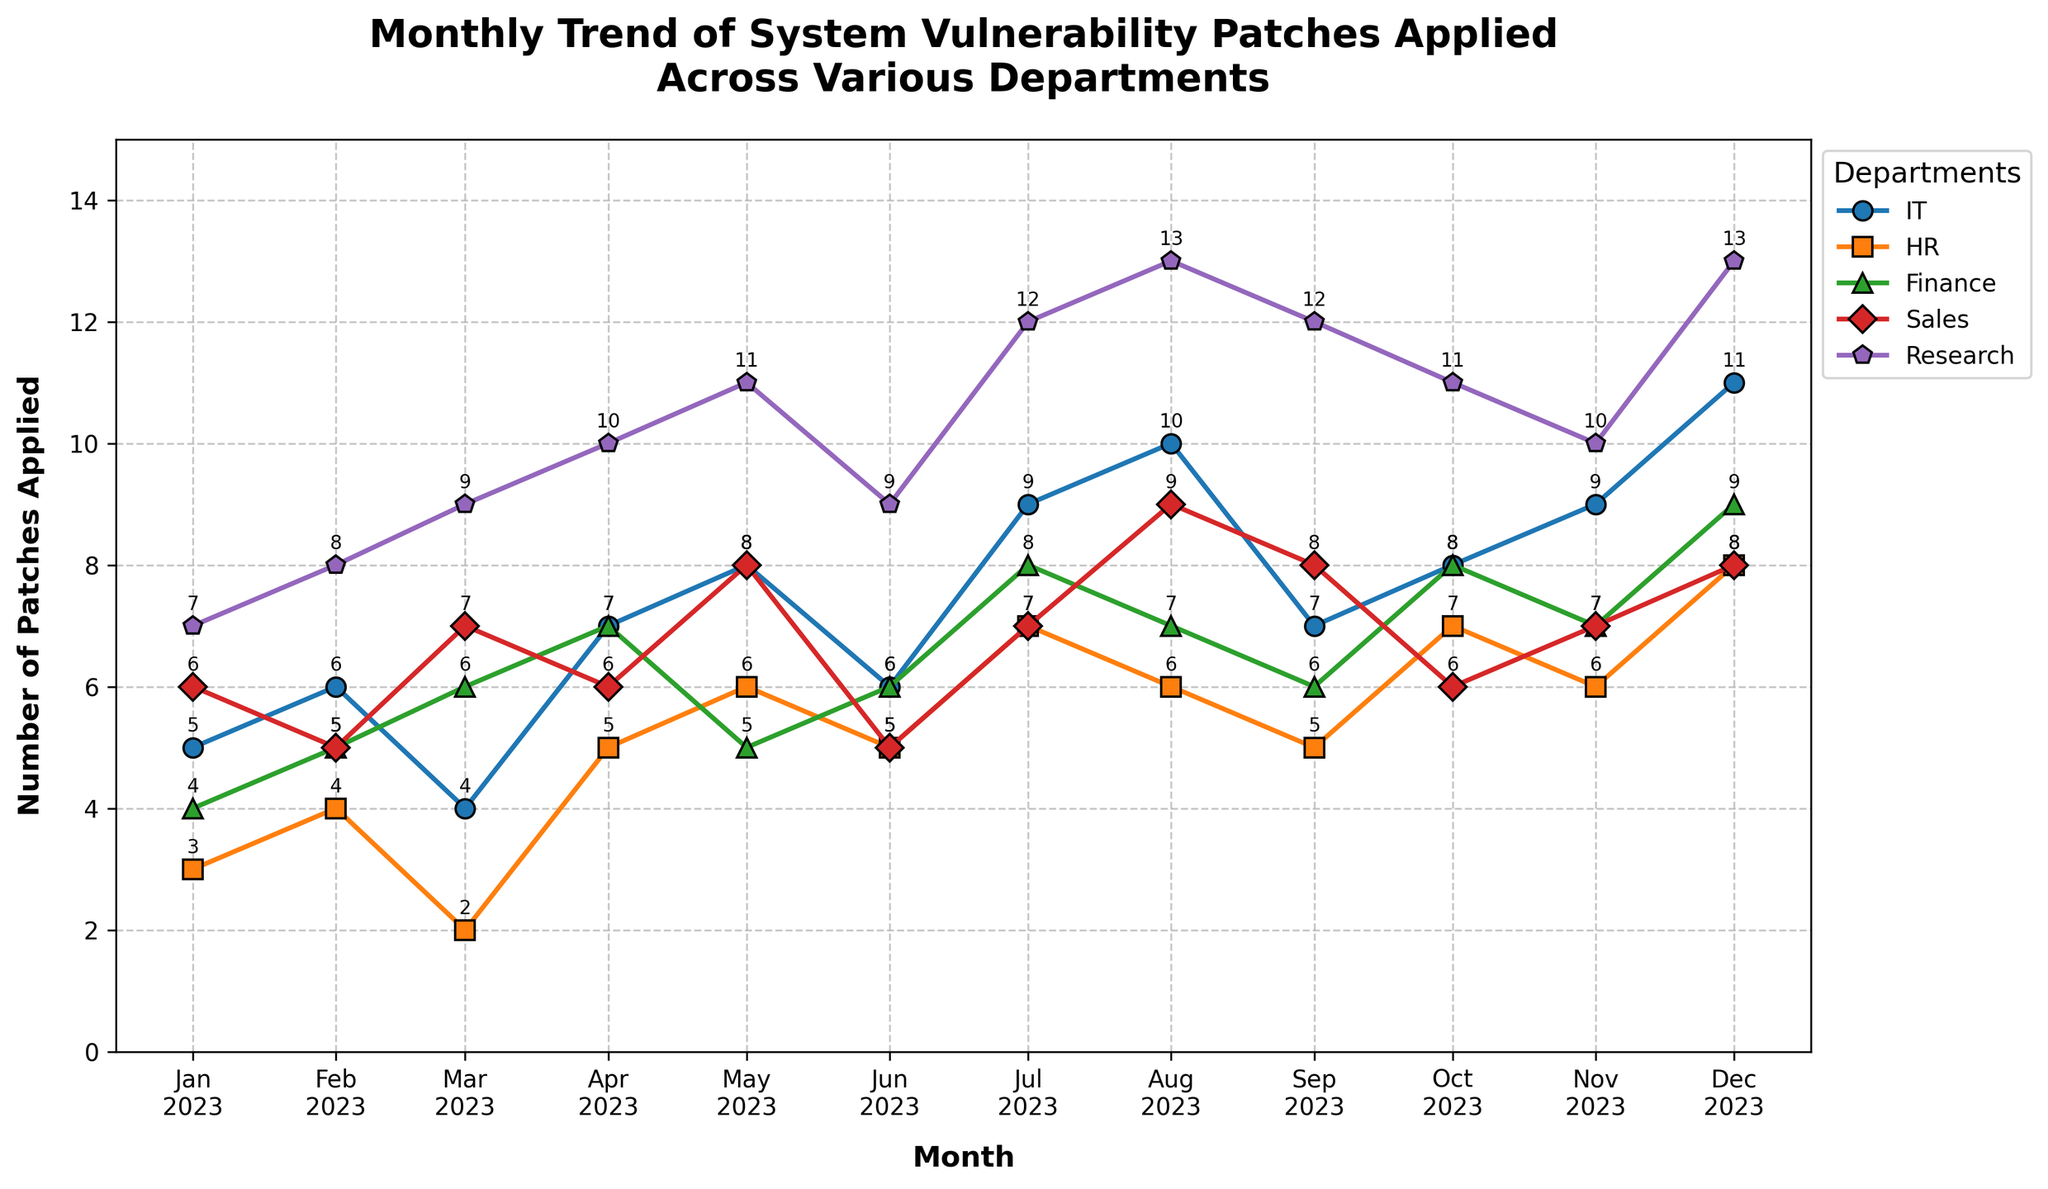What is the highest number of patches applied by the Research department in 2023? Observe the vertical axis and the line corresponding to the Research department, then identify the peak value. The highest value is marked.
Answer: 13 How many patches did the IT department apply in February 2023? Locate the February data point on the IT department's line and read the value next to it.
Answer: 6 Which department had the highest increase in patches from January to July 2023? Calculate the difference in patch numbers from January to July for each department, then compare the differences: IT (9-5=4), HR (7-3=4), Finance (8-4=4), Sales (7-6=1), Research (12-7=5). Research had the highest increase.
Answer: Research On average, how many patches did the HR department apply per month between January and December 2023? Sum the monthly patch numbers for HR and divide by 12: (3+4+2+5+6+5+7+6+5+7+6+8)/12=5
Answer: 5 During which month did the Sales department apply the least number of patches? Look for the lowest value on the Sales department's line and identify the corresponding month.
Answer: February How does the trend of patches applied in the Finance department compare between the last two months (November to December 2023)? Compare the values of patches applied in Finance in November (7) and December (9): The number increased from November to December.
Answer: Increased What is the overall trend of patches applied by all departments? Assess the general direction of the lines in the plot from January to December. Most departments show an upward trend indicating an increase in patches applied over time.
Answer: Increase In which month did the IT department apply more patches than the HR department by the largest margin? Calculate the difference in patches applied between IT and HR for each month, then identify the largest difference: November (9-6=3).
Answer: November Which department shows the most consistent number of patches applied through the year? Identify the department whose line has the smallest variation in value. The HR line has less fluctuation compared to others.
Answer: HR What is the combined number of patches applied by all departments in May 2023? Sum the patches applied by all departments in May: 8 (IT) + 6 (HR) + 5 (Finance) + 8 (Sales) + 11 (Research) = 38.
Answer: 38 